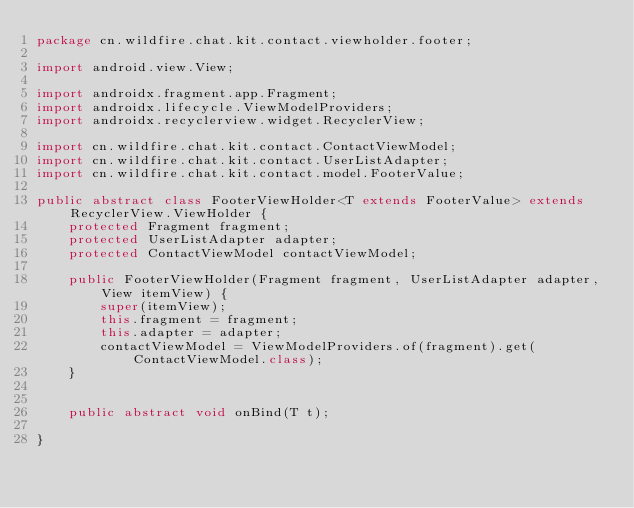<code> <loc_0><loc_0><loc_500><loc_500><_Java_>package cn.wildfire.chat.kit.contact.viewholder.footer;

import android.view.View;

import androidx.fragment.app.Fragment;
import androidx.lifecycle.ViewModelProviders;
import androidx.recyclerview.widget.RecyclerView;

import cn.wildfire.chat.kit.contact.ContactViewModel;
import cn.wildfire.chat.kit.contact.UserListAdapter;
import cn.wildfire.chat.kit.contact.model.FooterValue;

public abstract class FooterViewHolder<T extends FooterValue> extends RecyclerView.ViewHolder {
    protected Fragment fragment;
    protected UserListAdapter adapter;
    protected ContactViewModel contactViewModel;

    public FooterViewHolder(Fragment fragment, UserListAdapter adapter, View itemView) {
        super(itemView);
        this.fragment = fragment;
        this.adapter = adapter;
        contactViewModel = ViewModelProviders.of(fragment).get(ContactViewModel.class);
    }


    public abstract void onBind(T t);

}
</code> 